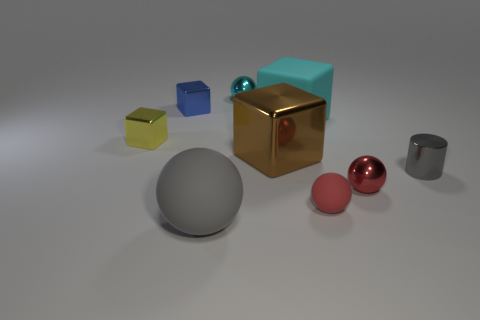Are any tiny red cylinders visible?
Give a very brief answer. No. Do the large matte object behind the tiny yellow object and the gray object that is to the left of the cyan shiny sphere have the same shape?
Keep it short and to the point. No. How many small objects are blue metallic things or gray matte things?
Provide a succinct answer. 1. There is a small blue thing that is the same material as the tiny yellow thing; what shape is it?
Provide a succinct answer. Cube. Is the shape of the tiny blue thing the same as the tiny yellow metallic object?
Your response must be concise. Yes. What is the color of the large matte ball?
Make the answer very short. Gray. What number of things are either small gray metallic cylinders or large brown metallic things?
Your response must be concise. 2. Is there any other thing that is made of the same material as the large cyan object?
Provide a succinct answer. Yes. Are there fewer cyan balls that are in front of the tiny shiny cylinder than yellow things?
Provide a short and direct response. Yes. Is the number of matte blocks that are in front of the gray rubber sphere greater than the number of blue cubes that are in front of the small blue object?
Provide a succinct answer. No. 